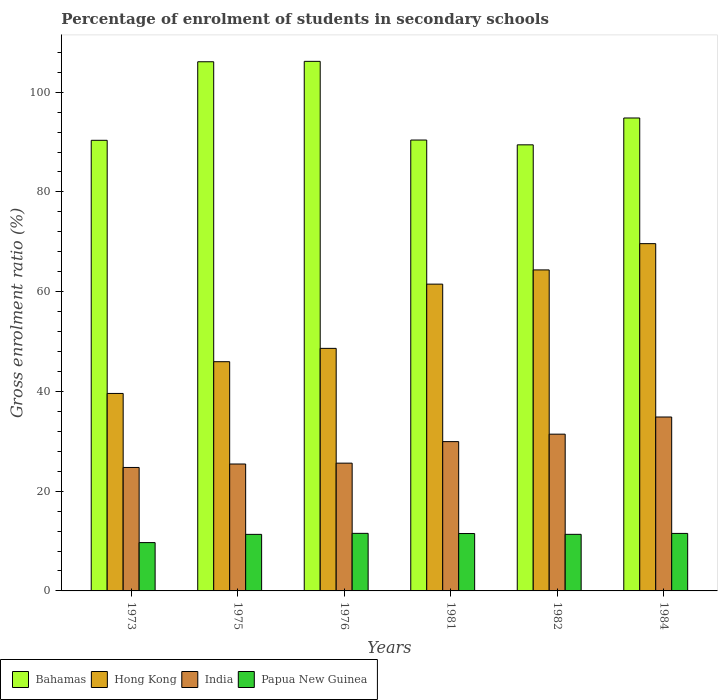How many groups of bars are there?
Keep it short and to the point. 6. Are the number of bars on each tick of the X-axis equal?
Your response must be concise. Yes. How many bars are there on the 1st tick from the right?
Your answer should be very brief. 4. What is the label of the 6th group of bars from the left?
Offer a very short reply. 1984. In how many cases, is the number of bars for a given year not equal to the number of legend labels?
Provide a short and direct response. 0. What is the percentage of students enrolled in secondary schools in Papua New Guinea in 1973?
Make the answer very short. 9.69. Across all years, what is the maximum percentage of students enrolled in secondary schools in Papua New Guinea?
Offer a terse response. 11.54. Across all years, what is the minimum percentage of students enrolled in secondary schools in Hong Kong?
Your answer should be compact. 39.59. What is the total percentage of students enrolled in secondary schools in Papua New Guinea in the graph?
Give a very brief answer. 66.95. What is the difference between the percentage of students enrolled in secondary schools in Hong Kong in 1973 and that in 1982?
Your answer should be compact. -24.77. What is the difference between the percentage of students enrolled in secondary schools in India in 1982 and the percentage of students enrolled in secondary schools in Papua New Guinea in 1976?
Provide a short and direct response. 19.89. What is the average percentage of students enrolled in secondary schools in Papua New Guinea per year?
Your answer should be very brief. 11.16. In the year 1984, what is the difference between the percentage of students enrolled in secondary schools in India and percentage of students enrolled in secondary schools in Bahamas?
Your response must be concise. -59.95. In how many years, is the percentage of students enrolled in secondary schools in Hong Kong greater than 64 %?
Give a very brief answer. 2. What is the ratio of the percentage of students enrolled in secondary schools in Bahamas in 1975 to that in 1984?
Keep it short and to the point. 1.12. Is the percentage of students enrolled in secondary schools in India in 1981 less than that in 1982?
Your answer should be very brief. Yes. Is the difference between the percentage of students enrolled in secondary schools in India in 1975 and 1976 greater than the difference between the percentage of students enrolled in secondary schools in Bahamas in 1975 and 1976?
Your answer should be compact. No. What is the difference between the highest and the second highest percentage of students enrolled in secondary schools in Hong Kong?
Make the answer very short. 5.26. What is the difference between the highest and the lowest percentage of students enrolled in secondary schools in Hong Kong?
Your answer should be compact. 30.03. In how many years, is the percentage of students enrolled in secondary schools in Bahamas greater than the average percentage of students enrolled in secondary schools in Bahamas taken over all years?
Your answer should be very brief. 2. What does the 1st bar from the left in 1981 represents?
Your answer should be compact. Bahamas. What does the 4th bar from the right in 1984 represents?
Provide a succinct answer. Bahamas. Are all the bars in the graph horizontal?
Provide a short and direct response. No. How many years are there in the graph?
Ensure brevity in your answer.  6. Does the graph contain any zero values?
Your answer should be compact. No. Where does the legend appear in the graph?
Give a very brief answer. Bottom left. How many legend labels are there?
Offer a terse response. 4. What is the title of the graph?
Keep it short and to the point. Percentage of enrolment of students in secondary schools. Does "French Polynesia" appear as one of the legend labels in the graph?
Keep it short and to the point. No. What is the label or title of the X-axis?
Your answer should be very brief. Years. What is the label or title of the Y-axis?
Give a very brief answer. Gross enrolment ratio (%). What is the Gross enrolment ratio (%) of Bahamas in 1973?
Provide a succinct answer. 90.34. What is the Gross enrolment ratio (%) in Hong Kong in 1973?
Offer a terse response. 39.59. What is the Gross enrolment ratio (%) of India in 1973?
Offer a very short reply. 24.75. What is the Gross enrolment ratio (%) in Papua New Guinea in 1973?
Provide a succinct answer. 9.69. What is the Gross enrolment ratio (%) in Bahamas in 1975?
Keep it short and to the point. 106.09. What is the Gross enrolment ratio (%) in Hong Kong in 1975?
Your answer should be compact. 45.96. What is the Gross enrolment ratio (%) of India in 1975?
Offer a terse response. 25.45. What is the Gross enrolment ratio (%) of Papua New Guinea in 1975?
Provide a succinct answer. 11.34. What is the Gross enrolment ratio (%) of Bahamas in 1976?
Your response must be concise. 106.17. What is the Gross enrolment ratio (%) of Hong Kong in 1976?
Make the answer very short. 48.63. What is the Gross enrolment ratio (%) of India in 1976?
Provide a short and direct response. 25.62. What is the Gross enrolment ratio (%) in Papua New Guinea in 1976?
Ensure brevity in your answer.  11.54. What is the Gross enrolment ratio (%) in Bahamas in 1981?
Your answer should be compact. 90.4. What is the Gross enrolment ratio (%) of Hong Kong in 1981?
Offer a terse response. 61.51. What is the Gross enrolment ratio (%) of India in 1981?
Your answer should be compact. 29.93. What is the Gross enrolment ratio (%) in Papua New Guinea in 1981?
Keep it short and to the point. 11.5. What is the Gross enrolment ratio (%) of Bahamas in 1982?
Your answer should be compact. 89.44. What is the Gross enrolment ratio (%) of Hong Kong in 1982?
Offer a very short reply. 64.36. What is the Gross enrolment ratio (%) in India in 1982?
Provide a succinct answer. 31.43. What is the Gross enrolment ratio (%) in Papua New Guinea in 1982?
Keep it short and to the point. 11.34. What is the Gross enrolment ratio (%) of Bahamas in 1984?
Provide a succinct answer. 94.82. What is the Gross enrolment ratio (%) of Hong Kong in 1984?
Provide a short and direct response. 69.62. What is the Gross enrolment ratio (%) of India in 1984?
Your answer should be compact. 34.87. What is the Gross enrolment ratio (%) in Papua New Guinea in 1984?
Your answer should be compact. 11.53. Across all years, what is the maximum Gross enrolment ratio (%) in Bahamas?
Keep it short and to the point. 106.17. Across all years, what is the maximum Gross enrolment ratio (%) of Hong Kong?
Provide a succinct answer. 69.62. Across all years, what is the maximum Gross enrolment ratio (%) in India?
Give a very brief answer. 34.87. Across all years, what is the maximum Gross enrolment ratio (%) of Papua New Guinea?
Make the answer very short. 11.54. Across all years, what is the minimum Gross enrolment ratio (%) of Bahamas?
Your response must be concise. 89.44. Across all years, what is the minimum Gross enrolment ratio (%) of Hong Kong?
Your answer should be very brief. 39.59. Across all years, what is the minimum Gross enrolment ratio (%) of India?
Provide a succinct answer. 24.75. Across all years, what is the minimum Gross enrolment ratio (%) of Papua New Guinea?
Your answer should be very brief. 9.69. What is the total Gross enrolment ratio (%) of Bahamas in the graph?
Give a very brief answer. 577.27. What is the total Gross enrolment ratio (%) in Hong Kong in the graph?
Offer a very short reply. 329.67. What is the total Gross enrolment ratio (%) of India in the graph?
Make the answer very short. 172.05. What is the total Gross enrolment ratio (%) of Papua New Guinea in the graph?
Make the answer very short. 66.95. What is the difference between the Gross enrolment ratio (%) in Bahamas in 1973 and that in 1975?
Provide a short and direct response. -15.75. What is the difference between the Gross enrolment ratio (%) in Hong Kong in 1973 and that in 1975?
Ensure brevity in your answer.  -6.37. What is the difference between the Gross enrolment ratio (%) of India in 1973 and that in 1975?
Ensure brevity in your answer.  -0.69. What is the difference between the Gross enrolment ratio (%) in Papua New Guinea in 1973 and that in 1975?
Your answer should be compact. -1.65. What is the difference between the Gross enrolment ratio (%) of Bahamas in 1973 and that in 1976?
Provide a succinct answer. -15.83. What is the difference between the Gross enrolment ratio (%) in Hong Kong in 1973 and that in 1976?
Ensure brevity in your answer.  -9.04. What is the difference between the Gross enrolment ratio (%) in India in 1973 and that in 1976?
Make the answer very short. -0.87. What is the difference between the Gross enrolment ratio (%) in Papua New Guinea in 1973 and that in 1976?
Provide a short and direct response. -1.85. What is the difference between the Gross enrolment ratio (%) in Bahamas in 1973 and that in 1981?
Keep it short and to the point. -0.05. What is the difference between the Gross enrolment ratio (%) of Hong Kong in 1973 and that in 1981?
Offer a terse response. -21.91. What is the difference between the Gross enrolment ratio (%) of India in 1973 and that in 1981?
Your answer should be compact. -5.18. What is the difference between the Gross enrolment ratio (%) in Papua New Guinea in 1973 and that in 1981?
Your answer should be very brief. -1.82. What is the difference between the Gross enrolment ratio (%) of Bahamas in 1973 and that in 1982?
Your response must be concise. 0.91. What is the difference between the Gross enrolment ratio (%) in Hong Kong in 1973 and that in 1982?
Your response must be concise. -24.77. What is the difference between the Gross enrolment ratio (%) in India in 1973 and that in 1982?
Your response must be concise. -6.68. What is the difference between the Gross enrolment ratio (%) in Papua New Guinea in 1973 and that in 1982?
Offer a very short reply. -1.66. What is the difference between the Gross enrolment ratio (%) of Bahamas in 1973 and that in 1984?
Your answer should be very brief. -4.47. What is the difference between the Gross enrolment ratio (%) in Hong Kong in 1973 and that in 1984?
Offer a terse response. -30.03. What is the difference between the Gross enrolment ratio (%) in India in 1973 and that in 1984?
Give a very brief answer. -10.12. What is the difference between the Gross enrolment ratio (%) in Papua New Guinea in 1973 and that in 1984?
Keep it short and to the point. -1.84. What is the difference between the Gross enrolment ratio (%) of Bahamas in 1975 and that in 1976?
Keep it short and to the point. -0.08. What is the difference between the Gross enrolment ratio (%) of Hong Kong in 1975 and that in 1976?
Offer a terse response. -2.67. What is the difference between the Gross enrolment ratio (%) in India in 1975 and that in 1976?
Provide a succinct answer. -0.17. What is the difference between the Gross enrolment ratio (%) in Papua New Guinea in 1975 and that in 1976?
Ensure brevity in your answer.  -0.2. What is the difference between the Gross enrolment ratio (%) of Bahamas in 1975 and that in 1981?
Ensure brevity in your answer.  15.7. What is the difference between the Gross enrolment ratio (%) of Hong Kong in 1975 and that in 1981?
Keep it short and to the point. -15.55. What is the difference between the Gross enrolment ratio (%) of India in 1975 and that in 1981?
Your answer should be compact. -4.49. What is the difference between the Gross enrolment ratio (%) of Papua New Guinea in 1975 and that in 1981?
Provide a succinct answer. -0.17. What is the difference between the Gross enrolment ratio (%) of Bahamas in 1975 and that in 1982?
Your answer should be compact. 16.66. What is the difference between the Gross enrolment ratio (%) in Hong Kong in 1975 and that in 1982?
Your answer should be very brief. -18.4. What is the difference between the Gross enrolment ratio (%) of India in 1975 and that in 1982?
Keep it short and to the point. -5.98. What is the difference between the Gross enrolment ratio (%) of Papua New Guinea in 1975 and that in 1982?
Keep it short and to the point. -0.01. What is the difference between the Gross enrolment ratio (%) of Bahamas in 1975 and that in 1984?
Make the answer very short. 11.28. What is the difference between the Gross enrolment ratio (%) of Hong Kong in 1975 and that in 1984?
Provide a succinct answer. -23.67. What is the difference between the Gross enrolment ratio (%) of India in 1975 and that in 1984?
Provide a succinct answer. -9.42. What is the difference between the Gross enrolment ratio (%) in Papua New Guinea in 1975 and that in 1984?
Your response must be concise. -0.19. What is the difference between the Gross enrolment ratio (%) of Bahamas in 1976 and that in 1981?
Offer a terse response. 15.78. What is the difference between the Gross enrolment ratio (%) of Hong Kong in 1976 and that in 1981?
Provide a succinct answer. -12.88. What is the difference between the Gross enrolment ratio (%) in India in 1976 and that in 1981?
Your answer should be very brief. -4.32. What is the difference between the Gross enrolment ratio (%) in Papua New Guinea in 1976 and that in 1981?
Your answer should be compact. 0.04. What is the difference between the Gross enrolment ratio (%) of Bahamas in 1976 and that in 1982?
Keep it short and to the point. 16.74. What is the difference between the Gross enrolment ratio (%) of Hong Kong in 1976 and that in 1982?
Offer a very short reply. -15.73. What is the difference between the Gross enrolment ratio (%) in India in 1976 and that in 1982?
Provide a short and direct response. -5.81. What is the difference between the Gross enrolment ratio (%) in Papua New Guinea in 1976 and that in 1982?
Make the answer very short. 0.2. What is the difference between the Gross enrolment ratio (%) in Bahamas in 1976 and that in 1984?
Keep it short and to the point. 11.36. What is the difference between the Gross enrolment ratio (%) in Hong Kong in 1976 and that in 1984?
Provide a succinct answer. -20.99. What is the difference between the Gross enrolment ratio (%) in India in 1976 and that in 1984?
Ensure brevity in your answer.  -9.25. What is the difference between the Gross enrolment ratio (%) of Papua New Guinea in 1976 and that in 1984?
Offer a very short reply. 0.01. What is the difference between the Gross enrolment ratio (%) in Bahamas in 1981 and that in 1982?
Your answer should be compact. 0.96. What is the difference between the Gross enrolment ratio (%) of Hong Kong in 1981 and that in 1982?
Ensure brevity in your answer.  -2.85. What is the difference between the Gross enrolment ratio (%) in India in 1981 and that in 1982?
Keep it short and to the point. -1.49. What is the difference between the Gross enrolment ratio (%) in Papua New Guinea in 1981 and that in 1982?
Your response must be concise. 0.16. What is the difference between the Gross enrolment ratio (%) in Bahamas in 1981 and that in 1984?
Offer a terse response. -4.42. What is the difference between the Gross enrolment ratio (%) in Hong Kong in 1981 and that in 1984?
Your answer should be compact. -8.12. What is the difference between the Gross enrolment ratio (%) in India in 1981 and that in 1984?
Offer a terse response. -4.93. What is the difference between the Gross enrolment ratio (%) of Papua New Guinea in 1981 and that in 1984?
Make the answer very short. -0.03. What is the difference between the Gross enrolment ratio (%) in Bahamas in 1982 and that in 1984?
Give a very brief answer. -5.38. What is the difference between the Gross enrolment ratio (%) in Hong Kong in 1982 and that in 1984?
Provide a short and direct response. -5.26. What is the difference between the Gross enrolment ratio (%) in India in 1982 and that in 1984?
Your answer should be very brief. -3.44. What is the difference between the Gross enrolment ratio (%) of Papua New Guinea in 1982 and that in 1984?
Offer a terse response. -0.19. What is the difference between the Gross enrolment ratio (%) in Bahamas in 1973 and the Gross enrolment ratio (%) in Hong Kong in 1975?
Provide a short and direct response. 44.39. What is the difference between the Gross enrolment ratio (%) of Bahamas in 1973 and the Gross enrolment ratio (%) of India in 1975?
Your answer should be compact. 64.9. What is the difference between the Gross enrolment ratio (%) in Bahamas in 1973 and the Gross enrolment ratio (%) in Papua New Guinea in 1975?
Offer a very short reply. 79.01. What is the difference between the Gross enrolment ratio (%) of Hong Kong in 1973 and the Gross enrolment ratio (%) of India in 1975?
Your answer should be compact. 14.15. What is the difference between the Gross enrolment ratio (%) of Hong Kong in 1973 and the Gross enrolment ratio (%) of Papua New Guinea in 1975?
Offer a very short reply. 28.26. What is the difference between the Gross enrolment ratio (%) in India in 1973 and the Gross enrolment ratio (%) in Papua New Guinea in 1975?
Keep it short and to the point. 13.41. What is the difference between the Gross enrolment ratio (%) in Bahamas in 1973 and the Gross enrolment ratio (%) in Hong Kong in 1976?
Offer a terse response. 41.71. What is the difference between the Gross enrolment ratio (%) in Bahamas in 1973 and the Gross enrolment ratio (%) in India in 1976?
Offer a terse response. 64.73. What is the difference between the Gross enrolment ratio (%) in Bahamas in 1973 and the Gross enrolment ratio (%) in Papua New Guinea in 1976?
Provide a short and direct response. 78.8. What is the difference between the Gross enrolment ratio (%) of Hong Kong in 1973 and the Gross enrolment ratio (%) of India in 1976?
Your answer should be compact. 13.97. What is the difference between the Gross enrolment ratio (%) of Hong Kong in 1973 and the Gross enrolment ratio (%) of Papua New Guinea in 1976?
Your response must be concise. 28.05. What is the difference between the Gross enrolment ratio (%) in India in 1973 and the Gross enrolment ratio (%) in Papua New Guinea in 1976?
Provide a succinct answer. 13.21. What is the difference between the Gross enrolment ratio (%) of Bahamas in 1973 and the Gross enrolment ratio (%) of Hong Kong in 1981?
Your response must be concise. 28.84. What is the difference between the Gross enrolment ratio (%) in Bahamas in 1973 and the Gross enrolment ratio (%) in India in 1981?
Keep it short and to the point. 60.41. What is the difference between the Gross enrolment ratio (%) in Bahamas in 1973 and the Gross enrolment ratio (%) in Papua New Guinea in 1981?
Your answer should be very brief. 78.84. What is the difference between the Gross enrolment ratio (%) in Hong Kong in 1973 and the Gross enrolment ratio (%) in India in 1981?
Make the answer very short. 9.66. What is the difference between the Gross enrolment ratio (%) in Hong Kong in 1973 and the Gross enrolment ratio (%) in Papua New Guinea in 1981?
Provide a succinct answer. 28.09. What is the difference between the Gross enrolment ratio (%) of India in 1973 and the Gross enrolment ratio (%) of Papua New Guinea in 1981?
Your answer should be very brief. 13.25. What is the difference between the Gross enrolment ratio (%) of Bahamas in 1973 and the Gross enrolment ratio (%) of Hong Kong in 1982?
Your answer should be very brief. 25.98. What is the difference between the Gross enrolment ratio (%) of Bahamas in 1973 and the Gross enrolment ratio (%) of India in 1982?
Provide a short and direct response. 58.92. What is the difference between the Gross enrolment ratio (%) of Bahamas in 1973 and the Gross enrolment ratio (%) of Papua New Guinea in 1982?
Your response must be concise. 79. What is the difference between the Gross enrolment ratio (%) in Hong Kong in 1973 and the Gross enrolment ratio (%) in India in 1982?
Provide a short and direct response. 8.16. What is the difference between the Gross enrolment ratio (%) in Hong Kong in 1973 and the Gross enrolment ratio (%) in Papua New Guinea in 1982?
Offer a terse response. 28.25. What is the difference between the Gross enrolment ratio (%) of India in 1973 and the Gross enrolment ratio (%) of Papua New Guinea in 1982?
Ensure brevity in your answer.  13.41. What is the difference between the Gross enrolment ratio (%) in Bahamas in 1973 and the Gross enrolment ratio (%) in Hong Kong in 1984?
Your answer should be very brief. 20.72. What is the difference between the Gross enrolment ratio (%) in Bahamas in 1973 and the Gross enrolment ratio (%) in India in 1984?
Make the answer very short. 55.48. What is the difference between the Gross enrolment ratio (%) of Bahamas in 1973 and the Gross enrolment ratio (%) of Papua New Guinea in 1984?
Keep it short and to the point. 78.81. What is the difference between the Gross enrolment ratio (%) in Hong Kong in 1973 and the Gross enrolment ratio (%) in India in 1984?
Your answer should be very brief. 4.73. What is the difference between the Gross enrolment ratio (%) of Hong Kong in 1973 and the Gross enrolment ratio (%) of Papua New Guinea in 1984?
Your response must be concise. 28.06. What is the difference between the Gross enrolment ratio (%) of India in 1973 and the Gross enrolment ratio (%) of Papua New Guinea in 1984?
Your response must be concise. 13.22. What is the difference between the Gross enrolment ratio (%) of Bahamas in 1975 and the Gross enrolment ratio (%) of Hong Kong in 1976?
Ensure brevity in your answer.  57.46. What is the difference between the Gross enrolment ratio (%) in Bahamas in 1975 and the Gross enrolment ratio (%) in India in 1976?
Keep it short and to the point. 80.48. What is the difference between the Gross enrolment ratio (%) in Bahamas in 1975 and the Gross enrolment ratio (%) in Papua New Guinea in 1976?
Give a very brief answer. 94.55. What is the difference between the Gross enrolment ratio (%) of Hong Kong in 1975 and the Gross enrolment ratio (%) of India in 1976?
Give a very brief answer. 20.34. What is the difference between the Gross enrolment ratio (%) in Hong Kong in 1975 and the Gross enrolment ratio (%) in Papua New Guinea in 1976?
Provide a short and direct response. 34.42. What is the difference between the Gross enrolment ratio (%) in India in 1975 and the Gross enrolment ratio (%) in Papua New Guinea in 1976?
Provide a short and direct response. 13.9. What is the difference between the Gross enrolment ratio (%) in Bahamas in 1975 and the Gross enrolment ratio (%) in Hong Kong in 1981?
Offer a terse response. 44.59. What is the difference between the Gross enrolment ratio (%) in Bahamas in 1975 and the Gross enrolment ratio (%) in India in 1981?
Your answer should be compact. 76.16. What is the difference between the Gross enrolment ratio (%) in Bahamas in 1975 and the Gross enrolment ratio (%) in Papua New Guinea in 1981?
Provide a succinct answer. 94.59. What is the difference between the Gross enrolment ratio (%) of Hong Kong in 1975 and the Gross enrolment ratio (%) of India in 1981?
Your answer should be compact. 16.02. What is the difference between the Gross enrolment ratio (%) of Hong Kong in 1975 and the Gross enrolment ratio (%) of Papua New Guinea in 1981?
Offer a very short reply. 34.45. What is the difference between the Gross enrolment ratio (%) of India in 1975 and the Gross enrolment ratio (%) of Papua New Guinea in 1981?
Ensure brevity in your answer.  13.94. What is the difference between the Gross enrolment ratio (%) of Bahamas in 1975 and the Gross enrolment ratio (%) of Hong Kong in 1982?
Provide a short and direct response. 41.73. What is the difference between the Gross enrolment ratio (%) of Bahamas in 1975 and the Gross enrolment ratio (%) of India in 1982?
Your answer should be very brief. 74.67. What is the difference between the Gross enrolment ratio (%) in Bahamas in 1975 and the Gross enrolment ratio (%) in Papua New Guinea in 1982?
Offer a terse response. 94.75. What is the difference between the Gross enrolment ratio (%) of Hong Kong in 1975 and the Gross enrolment ratio (%) of India in 1982?
Your answer should be very brief. 14.53. What is the difference between the Gross enrolment ratio (%) of Hong Kong in 1975 and the Gross enrolment ratio (%) of Papua New Guinea in 1982?
Give a very brief answer. 34.61. What is the difference between the Gross enrolment ratio (%) in India in 1975 and the Gross enrolment ratio (%) in Papua New Guinea in 1982?
Offer a terse response. 14.1. What is the difference between the Gross enrolment ratio (%) of Bahamas in 1975 and the Gross enrolment ratio (%) of Hong Kong in 1984?
Your response must be concise. 36.47. What is the difference between the Gross enrolment ratio (%) in Bahamas in 1975 and the Gross enrolment ratio (%) in India in 1984?
Your answer should be compact. 71.23. What is the difference between the Gross enrolment ratio (%) of Bahamas in 1975 and the Gross enrolment ratio (%) of Papua New Guinea in 1984?
Give a very brief answer. 94.56. What is the difference between the Gross enrolment ratio (%) in Hong Kong in 1975 and the Gross enrolment ratio (%) in India in 1984?
Offer a terse response. 11.09. What is the difference between the Gross enrolment ratio (%) in Hong Kong in 1975 and the Gross enrolment ratio (%) in Papua New Guinea in 1984?
Keep it short and to the point. 34.43. What is the difference between the Gross enrolment ratio (%) of India in 1975 and the Gross enrolment ratio (%) of Papua New Guinea in 1984?
Keep it short and to the point. 13.92. What is the difference between the Gross enrolment ratio (%) of Bahamas in 1976 and the Gross enrolment ratio (%) of Hong Kong in 1981?
Provide a short and direct response. 44.67. What is the difference between the Gross enrolment ratio (%) of Bahamas in 1976 and the Gross enrolment ratio (%) of India in 1981?
Offer a very short reply. 76.24. What is the difference between the Gross enrolment ratio (%) of Bahamas in 1976 and the Gross enrolment ratio (%) of Papua New Guinea in 1981?
Give a very brief answer. 94.67. What is the difference between the Gross enrolment ratio (%) of Hong Kong in 1976 and the Gross enrolment ratio (%) of India in 1981?
Ensure brevity in your answer.  18.7. What is the difference between the Gross enrolment ratio (%) in Hong Kong in 1976 and the Gross enrolment ratio (%) in Papua New Guinea in 1981?
Keep it short and to the point. 37.13. What is the difference between the Gross enrolment ratio (%) in India in 1976 and the Gross enrolment ratio (%) in Papua New Guinea in 1981?
Provide a succinct answer. 14.11. What is the difference between the Gross enrolment ratio (%) in Bahamas in 1976 and the Gross enrolment ratio (%) in Hong Kong in 1982?
Your response must be concise. 41.81. What is the difference between the Gross enrolment ratio (%) of Bahamas in 1976 and the Gross enrolment ratio (%) of India in 1982?
Ensure brevity in your answer.  74.75. What is the difference between the Gross enrolment ratio (%) in Bahamas in 1976 and the Gross enrolment ratio (%) in Papua New Guinea in 1982?
Give a very brief answer. 94.83. What is the difference between the Gross enrolment ratio (%) in Hong Kong in 1976 and the Gross enrolment ratio (%) in India in 1982?
Your response must be concise. 17.2. What is the difference between the Gross enrolment ratio (%) in Hong Kong in 1976 and the Gross enrolment ratio (%) in Papua New Guinea in 1982?
Keep it short and to the point. 37.29. What is the difference between the Gross enrolment ratio (%) of India in 1976 and the Gross enrolment ratio (%) of Papua New Guinea in 1982?
Offer a terse response. 14.27. What is the difference between the Gross enrolment ratio (%) of Bahamas in 1976 and the Gross enrolment ratio (%) of Hong Kong in 1984?
Provide a short and direct response. 36.55. What is the difference between the Gross enrolment ratio (%) of Bahamas in 1976 and the Gross enrolment ratio (%) of India in 1984?
Make the answer very short. 71.31. What is the difference between the Gross enrolment ratio (%) in Bahamas in 1976 and the Gross enrolment ratio (%) in Papua New Guinea in 1984?
Ensure brevity in your answer.  94.64. What is the difference between the Gross enrolment ratio (%) of Hong Kong in 1976 and the Gross enrolment ratio (%) of India in 1984?
Give a very brief answer. 13.76. What is the difference between the Gross enrolment ratio (%) of Hong Kong in 1976 and the Gross enrolment ratio (%) of Papua New Guinea in 1984?
Give a very brief answer. 37.1. What is the difference between the Gross enrolment ratio (%) of India in 1976 and the Gross enrolment ratio (%) of Papua New Guinea in 1984?
Ensure brevity in your answer.  14.09. What is the difference between the Gross enrolment ratio (%) of Bahamas in 1981 and the Gross enrolment ratio (%) of Hong Kong in 1982?
Offer a terse response. 26.04. What is the difference between the Gross enrolment ratio (%) of Bahamas in 1981 and the Gross enrolment ratio (%) of India in 1982?
Offer a terse response. 58.97. What is the difference between the Gross enrolment ratio (%) in Bahamas in 1981 and the Gross enrolment ratio (%) in Papua New Guinea in 1982?
Your response must be concise. 79.05. What is the difference between the Gross enrolment ratio (%) in Hong Kong in 1981 and the Gross enrolment ratio (%) in India in 1982?
Offer a very short reply. 30.08. What is the difference between the Gross enrolment ratio (%) of Hong Kong in 1981 and the Gross enrolment ratio (%) of Papua New Guinea in 1982?
Your answer should be very brief. 50.16. What is the difference between the Gross enrolment ratio (%) in India in 1981 and the Gross enrolment ratio (%) in Papua New Guinea in 1982?
Offer a terse response. 18.59. What is the difference between the Gross enrolment ratio (%) of Bahamas in 1981 and the Gross enrolment ratio (%) of Hong Kong in 1984?
Give a very brief answer. 20.77. What is the difference between the Gross enrolment ratio (%) in Bahamas in 1981 and the Gross enrolment ratio (%) in India in 1984?
Give a very brief answer. 55.53. What is the difference between the Gross enrolment ratio (%) in Bahamas in 1981 and the Gross enrolment ratio (%) in Papua New Guinea in 1984?
Ensure brevity in your answer.  78.87. What is the difference between the Gross enrolment ratio (%) in Hong Kong in 1981 and the Gross enrolment ratio (%) in India in 1984?
Ensure brevity in your answer.  26.64. What is the difference between the Gross enrolment ratio (%) of Hong Kong in 1981 and the Gross enrolment ratio (%) of Papua New Guinea in 1984?
Offer a terse response. 49.98. What is the difference between the Gross enrolment ratio (%) in India in 1981 and the Gross enrolment ratio (%) in Papua New Guinea in 1984?
Offer a terse response. 18.4. What is the difference between the Gross enrolment ratio (%) in Bahamas in 1982 and the Gross enrolment ratio (%) in Hong Kong in 1984?
Your response must be concise. 19.81. What is the difference between the Gross enrolment ratio (%) of Bahamas in 1982 and the Gross enrolment ratio (%) of India in 1984?
Offer a terse response. 54.57. What is the difference between the Gross enrolment ratio (%) in Bahamas in 1982 and the Gross enrolment ratio (%) in Papua New Guinea in 1984?
Your answer should be very brief. 77.91. What is the difference between the Gross enrolment ratio (%) of Hong Kong in 1982 and the Gross enrolment ratio (%) of India in 1984?
Offer a terse response. 29.49. What is the difference between the Gross enrolment ratio (%) in Hong Kong in 1982 and the Gross enrolment ratio (%) in Papua New Guinea in 1984?
Provide a short and direct response. 52.83. What is the difference between the Gross enrolment ratio (%) of India in 1982 and the Gross enrolment ratio (%) of Papua New Guinea in 1984?
Provide a succinct answer. 19.9. What is the average Gross enrolment ratio (%) of Bahamas per year?
Your answer should be very brief. 96.21. What is the average Gross enrolment ratio (%) in Hong Kong per year?
Your response must be concise. 54.95. What is the average Gross enrolment ratio (%) in India per year?
Your answer should be very brief. 28.67. What is the average Gross enrolment ratio (%) of Papua New Guinea per year?
Keep it short and to the point. 11.16. In the year 1973, what is the difference between the Gross enrolment ratio (%) of Bahamas and Gross enrolment ratio (%) of Hong Kong?
Provide a short and direct response. 50.75. In the year 1973, what is the difference between the Gross enrolment ratio (%) of Bahamas and Gross enrolment ratio (%) of India?
Offer a very short reply. 65.59. In the year 1973, what is the difference between the Gross enrolment ratio (%) of Bahamas and Gross enrolment ratio (%) of Papua New Guinea?
Your answer should be very brief. 80.66. In the year 1973, what is the difference between the Gross enrolment ratio (%) of Hong Kong and Gross enrolment ratio (%) of India?
Offer a very short reply. 14.84. In the year 1973, what is the difference between the Gross enrolment ratio (%) of Hong Kong and Gross enrolment ratio (%) of Papua New Guinea?
Your response must be concise. 29.9. In the year 1973, what is the difference between the Gross enrolment ratio (%) in India and Gross enrolment ratio (%) in Papua New Guinea?
Make the answer very short. 15.06. In the year 1975, what is the difference between the Gross enrolment ratio (%) of Bahamas and Gross enrolment ratio (%) of Hong Kong?
Give a very brief answer. 60.14. In the year 1975, what is the difference between the Gross enrolment ratio (%) of Bahamas and Gross enrolment ratio (%) of India?
Your answer should be very brief. 80.65. In the year 1975, what is the difference between the Gross enrolment ratio (%) in Bahamas and Gross enrolment ratio (%) in Papua New Guinea?
Offer a terse response. 94.76. In the year 1975, what is the difference between the Gross enrolment ratio (%) in Hong Kong and Gross enrolment ratio (%) in India?
Make the answer very short. 20.51. In the year 1975, what is the difference between the Gross enrolment ratio (%) in Hong Kong and Gross enrolment ratio (%) in Papua New Guinea?
Your answer should be very brief. 34.62. In the year 1975, what is the difference between the Gross enrolment ratio (%) of India and Gross enrolment ratio (%) of Papua New Guinea?
Offer a very short reply. 14.11. In the year 1976, what is the difference between the Gross enrolment ratio (%) in Bahamas and Gross enrolment ratio (%) in Hong Kong?
Keep it short and to the point. 57.54. In the year 1976, what is the difference between the Gross enrolment ratio (%) in Bahamas and Gross enrolment ratio (%) in India?
Keep it short and to the point. 80.56. In the year 1976, what is the difference between the Gross enrolment ratio (%) in Bahamas and Gross enrolment ratio (%) in Papua New Guinea?
Provide a succinct answer. 94.63. In the year 1976, what is the difference between the Gross enrolment ratio (%) of Hong Kong and Gross enrolment ratio (%) of India?
Offer a very short reply. 23.01. In the year 1976, what is the difference between the Gross enrolment ratio (%) in Hong Kong and Gross enrolment ratio (%) in Papua New Guinea?
Your answer should be very brief. 37.09. In the year 1976, what is the difference between the Gross enrolment ratio (%) of India and Gross enrolment ratio (%) of Papua New Guinea?
Provide a short and direct response. 14.08. In the year 1981, what is the difference between the Gross enrolment ratio (%) of Bahamas and Gross enrolment ratio (%) of Hong Kong?
Your response must be concise. 28.89. In the year 1981, what is the difference between the Gross enrolment ratio (%) of Bahamas and Gross enrolment ratio (%) of India?
Offer a very short reply. 60.46. In the year 1981, what is the difference between the Gross enrolment ratio (%) of Bahamas and Gross enrolment ratio (%) of Papua New Guinea?
Your answer should be very brief. 78.89. In the year 1981, what is the difference between the Gross enrolment ratio (%) of Hong Kong and Gross enrolment ratio (%) of India?
Offer a terse response. 31.57. In the year 1981, what is the difference between the Gross enrolment ratio (%) in Hong Kong and Gross enrolment ratio (%) in Papua New Guinea?
Make the answer very short. 50. In the year 1981, what is the difference between the Gross enrolment ratio (%) in India and Gross enrolment ratio (%) in Papua New Guinea?
Offer a very short reply. 18.43. In the year 1982, what is the difference between the Gross enrolment ratio (%) in Bahamas and Gross enrolment ratio (%) in Hong Kong?
Make the answer very short. 25.08. In the year 1982, what is the difference between the Gross enrolment ratio (%) of Bahamas and Gross enrolment ratio (%) of India?
Keep it short and to the point. 58.01. In the year 1982, what is the difference between the Gross enrolment ratio (%) in Bahamas and Gross enrolment ratio (%) in Papua New Guinea?
Provide a short and direct response. 78.09. In the year 1982, what is the difference between the Gross enrolment ratio (%) in Hong Kong and Gross enrolment ratio (%) in India?
Offer a terse response. 32.93. In the year 1982, what is the difference between the Gross enrolment ratio (%) of Hong Kong and Gross enrolment ratio (%) of Papua New Guinea?
Ensure brevity in your answer.  53.02. In the year 1982, what is the difference between the Gross enrolment ratio (%) of India and Gross enrolment ratio (%) of Papua New Guinea?
Provide a short and direct response. 20.08. In the year 1984, what is the difference between the Gross enrolment ratio (%) of Bahamas and Gross enrolment ratio (%) of Hong Kong?
Keep it short and to the point. 25.19. In the year 1984, what is the difference between the Gross enrolment ratio (%) in Bahamas and Gross enrolment ratio (%) in India?
Make the answer very short. 59.95. In the year 1984, what is the difference between the Gross enrolment ratio (%) in Bahamas and Gross enrolment ratio (%) in Papua New Guinea?
Provide a succinct answer. 83.29. In the year 1984, what is the difference between the Gross enrolment ratio (%) in Hong Kong and Gross enrolment ratio (%) in India?
Ensure brevity in your answer.  34.76. In the year 1984, what is the difference between the Gross enrolment ratio (%) in Hong Kong and Gross enrolment ratio (%) in Papua New Guinea?
Your response must be concise. 58.09. In the year 1984, what is the difference between the Gross enrolment ratio (%) in India and Gross enrolment ratio (%) in Papua New Guinea?
Offer a very short reply. 23.34. What is the ratio of the Gross enrolment ratio (%) in Bahamas in 1973 to that in 1975?
Keep it short and to the point. 0.85. What is the ratio of the Gross enrolment ratio (%) in Hong Kong in 1973 to that in 1975?
Keep it short and to the point. 0.86. What is the ratio of the Gross enrolment ratio (%) in India in 1973 to that in 1975?
Your response must be concise. 0.97. What is the ratio of the Gross enrolment ratio (%) in Papua New Guinea in 1973 to that in 1975?
Ensure brevity in your answer.  0.85. What is the ratio of the Gross enrolment ratio (%) in Bahamas in 1973 to that in 1976?
Your response must be concise. 0.85. What is the ratio of the Gross enrolment ratio (%) in Hong Kong in 1973 to that in 1976?
Make the answer very short. 0.81. What is the ratio of the Gross enrolment ratio (%) in India in 1973 to that in 1976?
Your response must be concise. 0.97. What is the ratio of the Gross enrolment ratio (%) in Papua New Guinea in 1973 to that in 1976?
Your answer should be very brief. 0.84. What is the ratio of the Gross enrolment ratio (%) in Hong Kong in 1973 to that in 1981?
Give a very brief answer. 0.64. What is the ratio of the Gross enrolment ratio (%) of India in 1973 to that in 1981?
Provide a short and direct response. 0.83. What is the ratio of the Gross enrolment ratio (%) in Papua New Guinea in 1973 to that in 1981?
Give a very brief answer. 0.84. What is the ratio of the Gross enrolment ratio (%) in Hong Kong in 1973 to that in 1982?
Give a very brief answer. 0.62. What is the ratio of the Gross enrolment ratio (%) in India in 1973 to that in 1982?
Your response must be concise. 0.79. What is the ratio of the Gross enrolment ratio (%) in Papua New Guinea in 1973 to that in 1982?
Your answer should be compact. 0.85. What is the ratio of the Gross enrolment ratio (%) in Bahamas in 1973 to that in 1984?
Make the answer very short. 0.95. What is the ratio of the Gross enrolment ratio (%) of Hong Kong in 1973 to that in 1984?
Provide a succinct answer. 0.57. What is the ratio of the Gross enrolment ratio (%) of India in 1973 to that in 1984?
Provide a short and direct response. 0.71. What is the ratio of the Gross enrolment ratio (%) of Papua New Guinea in 1973 to that in 1984?
Keep it short and to the point. 0.84. What is the ratio of the Gross enrolment ratio (%) in Bahamas in 1975 to that in 1976?
Provide a succinct answer. 1. What is the ratio of the Gross enrolment ratio (%) of Hong Kong in 1975 to that in 1976?
Give a very brief answer. 0.95. What is the ratio of the Gross enrolment ratio (%) in India in 1975 to that in 1976?
Keep it short and to the point. 0.99. What is the ratio of the Gross enrolment ratio (%) of Papua New Guinea in 1975 to that in 1976?
Offer a terse response. 0.98. What is the ratio of the Gross enrolment ratio (%) in Bahamas in 1975 to that in 1981?
Ensure brevity in your answer.  1.17. What is the ratio of the Gross enrolment ratio (%) of Hong Kong in 1975 to that in 1981?
Your answer should be compact. 0.75. What is the ratio of the Gross enrolment ratio (%) of India in 1975 to that in 1981?
Your response must be concise. 0.85. What is the ratio of the Gross enrolment ratio (%) in Papua New Guinea in 1975 to that in 1981?
Provide a succinct answer. 0.99. What is the ratio of the Gross enrolment ratio (%) in Bahamas in 1975 to that in 1982?
Your response must be concise. 1.19. What is the ratio of the Gross enrolment ratio (%) in Hong Kong in 1975 to that in 1982?
Give a very brief answer. 0.71. What is the ratio of the Gross enrolment ratio (%) in India in 1975 to that in 1982?
Offer a terse response. 0.81. What is the ratio of the Gross enrolment ratio (%) in Papua New Guinea in 1975 to that in 1982?
Keep it short and to the point. 1. What is the ratio of the Gross enrolment ratio (%) of Bahamas in 1975 to that in 1984?
Provide a succinct answer. 1.12. What is the ratio of the Gross enrolment ratio (%) in Hong Kong in 1975 to that in 1984?
Your answer should be very brief. 0.66. What is the ratio of the Gross enrolment ratio (%) of India in 1975 to that in 1984?
Give a very brief answer. 0.73. What is the ratio of the Gross enrolment ratio (%) of Papua New Guinea in 1975 to that in 1984?
Your answer should be very brief. 0.98. What is the ratio of the Gross enrolment ratio (%) of Bahamas in 1976 to that in 1981?
Make the answer very short. 1.17. What is the ratio of the Gross enrolment ratio (%) in Hong Kong in 1976 to that in 1981?
Your response must be concise. 0.79. What is the ratio of the Gross enrolment ratio (%) of India in 1976 to that in 1981?
Offer a terse response. 0.86. What is the ratio of the Gross enrolment ratio (%) of Bahamas in 1976 to that in 1982?
Offer a terse response. 1.19. What is the ratio of the Gross enrolment ratio (%) of Hong Kong in 1976 to that in 1982?
Your answer should be compact. 0.76. What is the ratio of the Gross enrolment ratio (%) in India in 1976 to that in 1982?
Your answer should be compact. 0.82. What is the ratio of the Gross enrolment ratio (%) in Papua New Guinea in 1976 to that in 1982?
Offer a terse response. 1.02. What is the ratio of the Gross enrolment ratio (%) in Bahamas in 1976 to that in 1984?
Keep it short and to the point. 1.12. What is the ratio of the Gross enrolment ratio (%) in Hong Kong in 1976 to that in 1984?
Ensure brevity in your answer.  0.7. What is the ratio of the Gross enrolment ratio (%) of India in 1976 to that in 1984?
Offer a terse response. 0.73. What is the ratio of the Gross enrolment ratio (%) of Bahamas in 1981 to that in 1982?
Ensure brevity in your answer.  1.01. What is the ratio of the Gross enrolment ratio (%) of Hong Kong in 1981 to that in 1982?
Make the answer very short. 0.96. What is the ratio of the Gross enrolment ratio (%) of India in 1981 to that in 1982?
Keep it short and to the point. 0.95. What is the ratio of the Gross enrolment ratio (%) in Papua New Guinea in 1981 to that in 1982?
Your response must be concise. 1.01. What is the ratio of the Gross enrolment ratio (%) of Bahamas in 1981 to that in 1984?
Your response must be concise. 0.95. What is the ratio of the Gross enrolment ratio (%) of Hong Kong in 1981 to that in 1984?
Offer a terse response. 0.88. What is the ratio of the Gross enrolment ratio (%) in India in 1981 to that in 1984?
Your answer should be very brief. 0.86. What is the ratio of the Gross enrolment ratio (%) in Bahamas in 1982 to that in 1984?
Your response must be concise. 0.94. What is the ratio of the Gross enrolment ratio (%) in Hong Kong in 1982 to that in 1984?
Make the answer very short. 0.92. What is the ratio of the Gross enrolment ratio (%) in India in 1982 to that in 1984?
Provide a succinct answer. 0.9. What is the ratio of the Gross enrolment ratio (%) in Papua New Guinea in 1982 to that in 1984?
Provide a succinct answer. 0.98. What is the difference between the highest and the second highest Gross enrolment ratio (%) in Bahamas?
Your answer should be very brief. 0.08. What is the difference between the highest and the second highest Gross enrolment ratio (%) in Hong Kong?
Give a very brief answer. 5.26. What is the difference between the highest and the second highest Gross enrolment ratio (%) of India?
Provide a short and direct response. 3.44. What is the difference between the highest and the second highest Gross enrolment ratio (%) in Papua New Guinea?
Give a very brief answer. 0.01. What is the difference between the highest and the lowest Gross enrolment ratio (%) in Bahamas?
Keep it short and to the point. 16.74. What is the difference between the highest and the lowest Gross enrolment ratio (%) in Hong Kong?
Provide a short and direct response. 30.03. What is the difference between the highest and the lowest Gross enrolment ratio (%) in India?
Keep it short and to the point. 10.12. What is the difference between the highest and the lowest Gross enrolment ratio (%) of Papua New Guinea?
Make the answer very short. 1.85. 